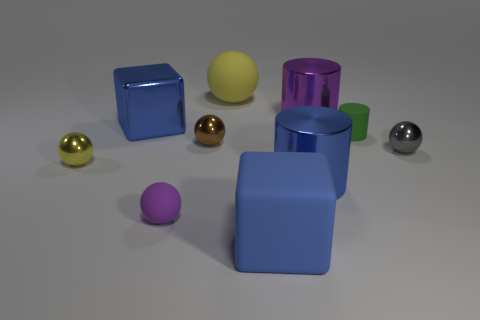How big is the cylinder that is both in front of the large purple shiny cylinder and on the left side of the small green matte object?
Your answer should be very brief. Large. How many spheres are either small brown objects or tiny purple objects?
Provide a succinct answer. 2. Are there any purple things that are to the left of the yellow thing to the right of the yellow thing that is in front of the big yellow thing?
Your answer should be very brief. Yes. What color is the other rubber object that is the same shape as the big yellow matte thing?
Offer a terse response. Purple. What number of blue things are either cubes or small metal things?
Your response must be concise. 2. What is the ball that is in front of the big shiny cylinder in front of the small yellow shiny object made of?
Provide a short and direct response. Rubber. Does the tiny gray metallic object have the same shape as the purple matte object?
Your response must be concise. Yes. What is the color of the cylinder that is the same size as the gray shiny object?
Provide a short and direct response. Green. Is there a small shiny thing of the same color as the metal cube?
Provide a succinct answer. No. Is there a blue shiny sphere?
Ensure brevity in your answer.  No. 